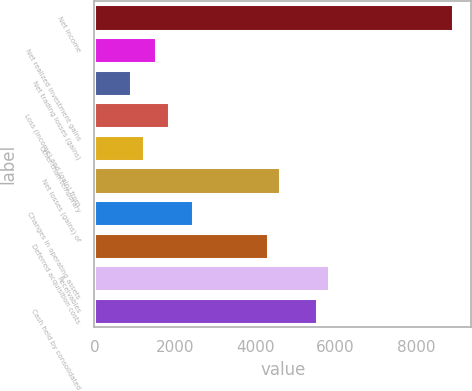Convert chart. <chart><loc_0><loc_0><loc_500><loc_500><bar_chart><fcel>Net income<fcel>Net realized investment gains<fcel>Net trading losses (gains)<fcel>Loss (income) and (gain) from<fcel>Other-than-temporary<fcel>Net losses (gains) of<fcel>Changes in operating assets<fcel>Deferred acquisition costs<fcel>Receivables<fcel>Cash held by consolidated<nl><fcel>8921.4<fcel>1539<fcel>923.8<fcel>1846.6<fcel>1231.4<fcel>4615<fcel>2461.8<fcel>4307.4<fcel>5845.4<fcel>5537.8<nl></chart> 